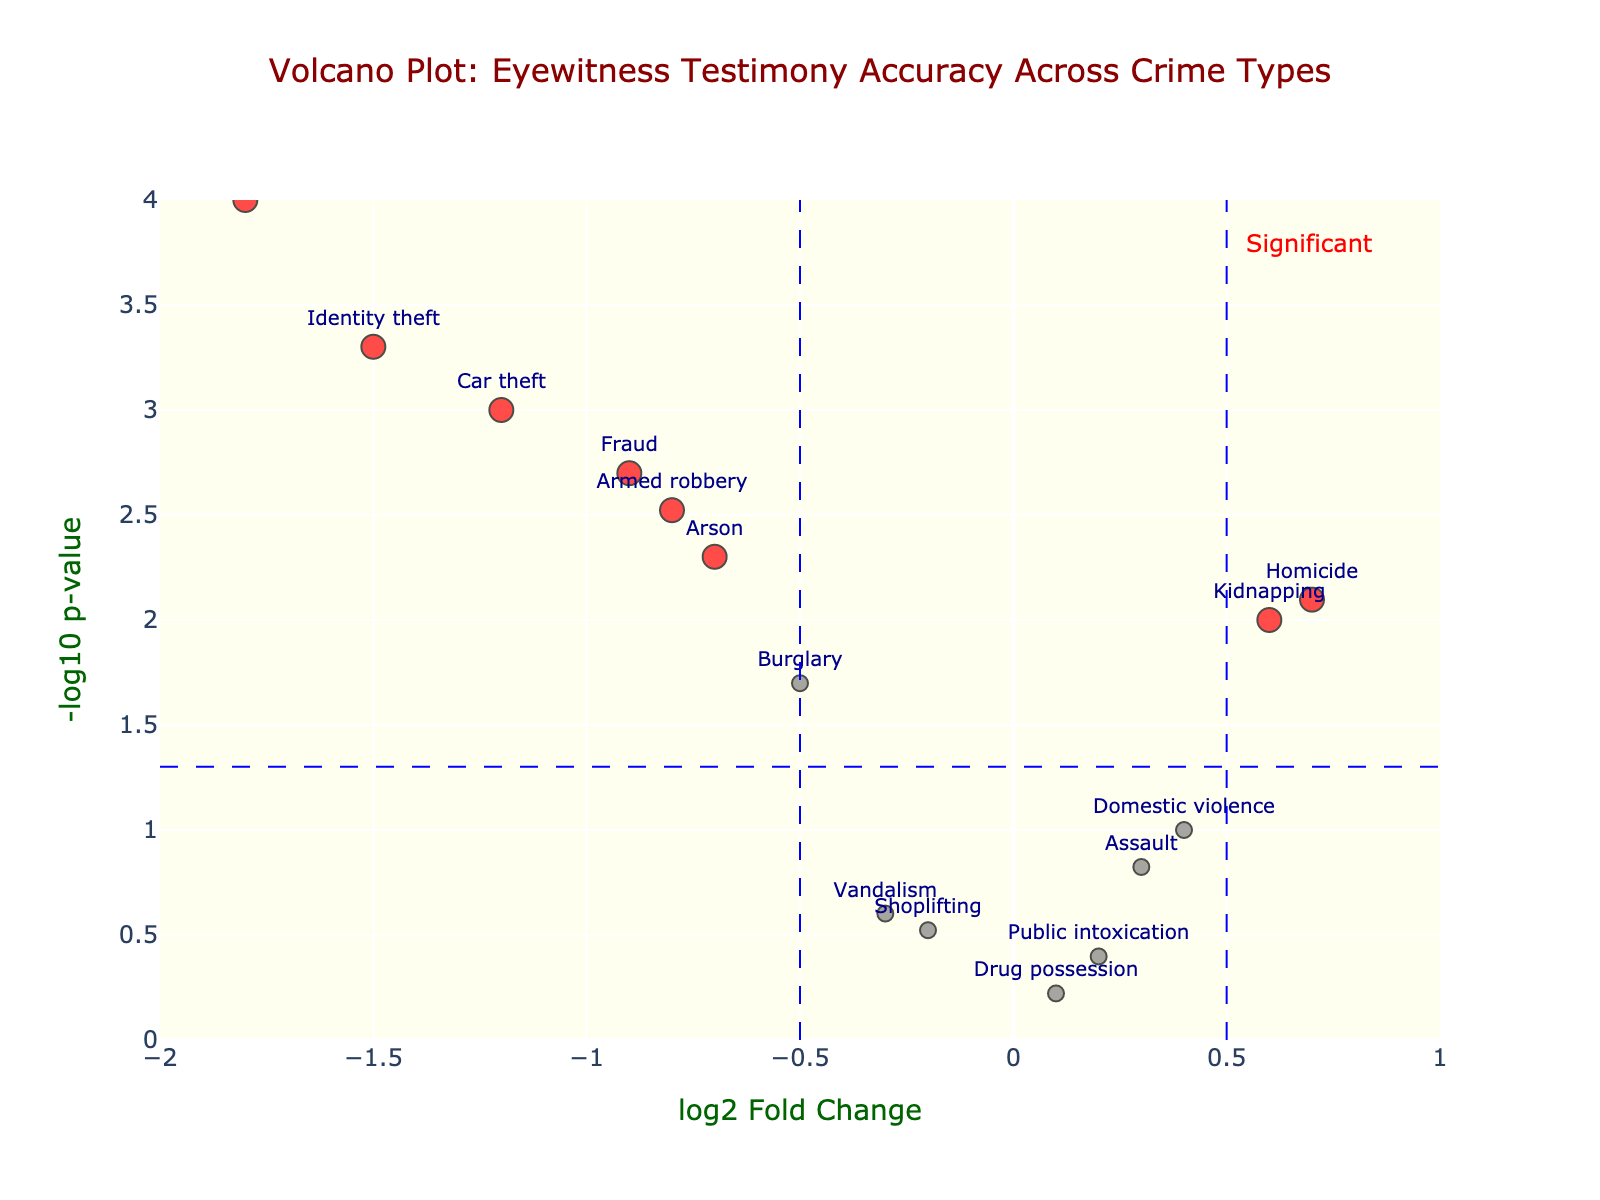What is the title of the figure? The title of the figure is clearly displayed at the top and reads "Volcano Plot: Eyewitness Testimony Accuracy Across Crime Types."
Answer: Volcano Plot: Eyewitness Testimony Accuracy Across Crime Types What does the x-axis represent? The x-axis represents the log2 fold change, which is labeled as "log2 Fold Change."
Answer: log2 Fold Change What does the y-axis represent? The y-axis represents the -log10 p-value, which is labeled as "-log10 p-value."
Answer: -log10 p-value How many data points are colored in red? By examining the color of each data point, we can see there are more data points colored in red compared to others. Specifically, there are five red points.
Answer: 5 Which crime type has the highest -log10 p-value? By looking at the y-axis values, the highest point on the y-axis corresponds to the data point for Cybercrime.
Answer: Cybercrime Which crime type has the highest log2 fold change? The highest log2 fold change, on the positive side of the x-axis, corresponds to Homicide with a value of 0.7.
Answer: Homicide Which crime types are considered statistically significant? Crime types that are colored red and above the horizontal significance threshold line near 1.3 on the y-axis are significant. These are Cybercrime, Identity theft, Car theft, Fraud, Armed robbery, Arson, Homicide, and Kidnapping.
Answer: Cybercrime, Identity theft, Car theft, Fraud, Armed robbery, Arson, Homicide, Kidnapping What is the log2 fold change range for all data points? By examining the x-axis range of the figure, we can see that it spans from -2 to 1.
Answer: -2 to 1 Compare the -log10 p-value of Fraud and Burglary. Which is higher? By identifying and comparing their positions on the y-axis, we see that Fraud is higher with a value near 3 compared to Burglary, which is just above 1.
Answer: Fraud Which crime types have a negative log2 fold change and a significant p-value? By locating data points with negative log2 fold change and red colors, these crime types are: Cybercrime, Identity theft, Car theft, Fraud, Armed robbery, and Arson.
Answer: Cybercrime, Identity theft, Car theft, Fraud, Armed robbery, Arson 